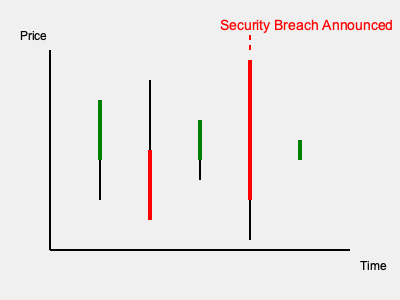Based on the candlestick chart above, which shows market activity before and after a high-profile security breach announcement, what trend can be observed in investor confidence immediately following the breach? To analyze the trend in investor confidence following the security breach, we need to examine the candlestick chart:

1. Identify the breach announcement: The red dashed line and text indicate the security breach announcement.

2. Observe the candlestick immediately after the breach:
   - It's a long red candlestick, indicating a significant price drop.
   - The long body suggests a strong downward movement from open to close.

3. Compare with previous candlesticks:
   - Prior to the breach, there were both green and red candlesticks with varying lengths.
   - The post-breach candlestick is notably longer and red, indicating a more dramatic price decrease.

4. Analyze the final candlestick:
   - It's a short green candlestick, suggesting a small recovery but still at a lower price level than before the breach.

5. Interpret the pattern:
   - The long red candlestick after the breach indicates a sharp sell-off.
   - This suggests a significant loss of investor confidence immediately following the security breach announcement.

6. Consider the impact on investor behavior:
   - The dramatic price drop likely reflects investors quickly selling their positions due to increased perceived risk.
   - This rapid selling pressure is a clear sign of diminished investor confidence in the short term.
Answer: Sharp decline in investor confidence 